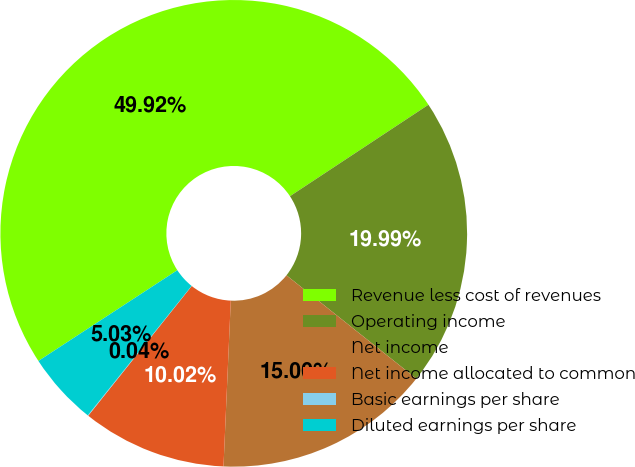<chart> <loc_0><loc_0><loc_500><loc_500><pie_chart><fcel>Revenue less cost of revenues<fcel>Operating income<fcel>Net income<fcel>Net income allocated to common<fcel>Basic earnings per share<fcel>Diluted earnings per share<nl><fcel>49.92%<fcel>19.99%<fcel>15.0%<fcel>10.02%<fcel>0.04%<fcel>5.03%<nl></chart> 